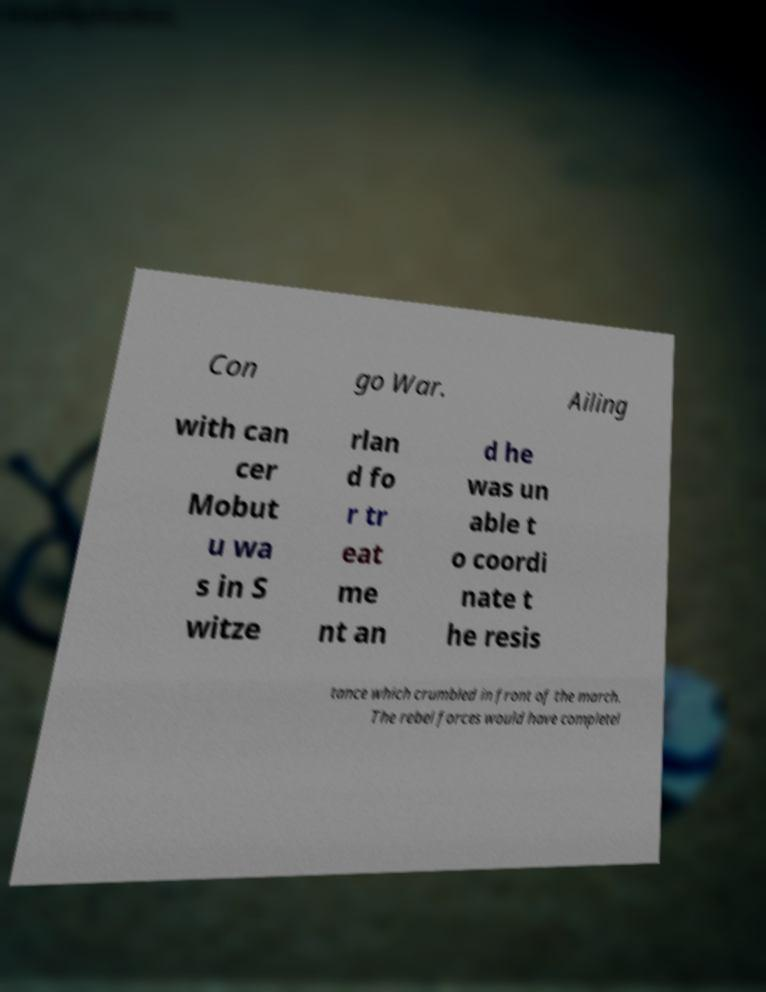Could you extract and type out the text from this image? Con go War. Ailing with can cer Mobut u wa s in S witze rlan d fo r tr eat me nt an d he was un able t o coordi nate t he resis tance which crumbled in front of the march. The rebel forces would have completel 